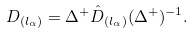<formula> <loc_0><loc_0><loc_500><loc_500>D _ { ( l _ { \alpha } ) } = \Delta ^ { + } \hat { D } _ { ( l _ { \alpha } ) } ( \Delta ^ { + } ) ^ { - 1 } .</formula> 